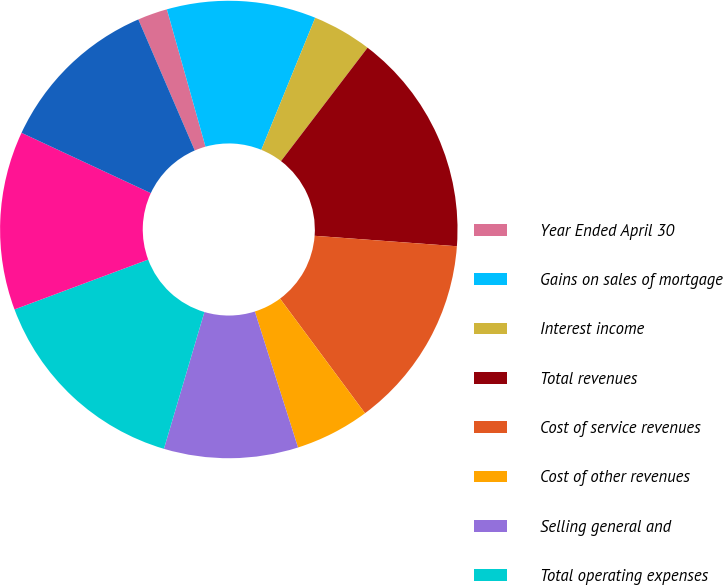Convert chart. <chart><loc_0><loc_0><loc_500><loc_500><pie_chart><fcel>Year Ended April 30<fcel>Gains on sales of mortgage<fcel>Interest income<fcel>Total revenues<fcel>Cost of service revenues<fcel>Cost of other revenues<fcel>Selling general and<fcel>Total operating expenses<fcel>Operating income<fcel>Income before taxes<nl><fcel>2.11%<fcel>10.53%<fcel>4.21%<fcel>15.79%<fcel>13.68%<fcel>5.26%<fcel>9.47%<fcel>14.74%<fcel>12.63%<fcel>11.58%<nl></chart> 